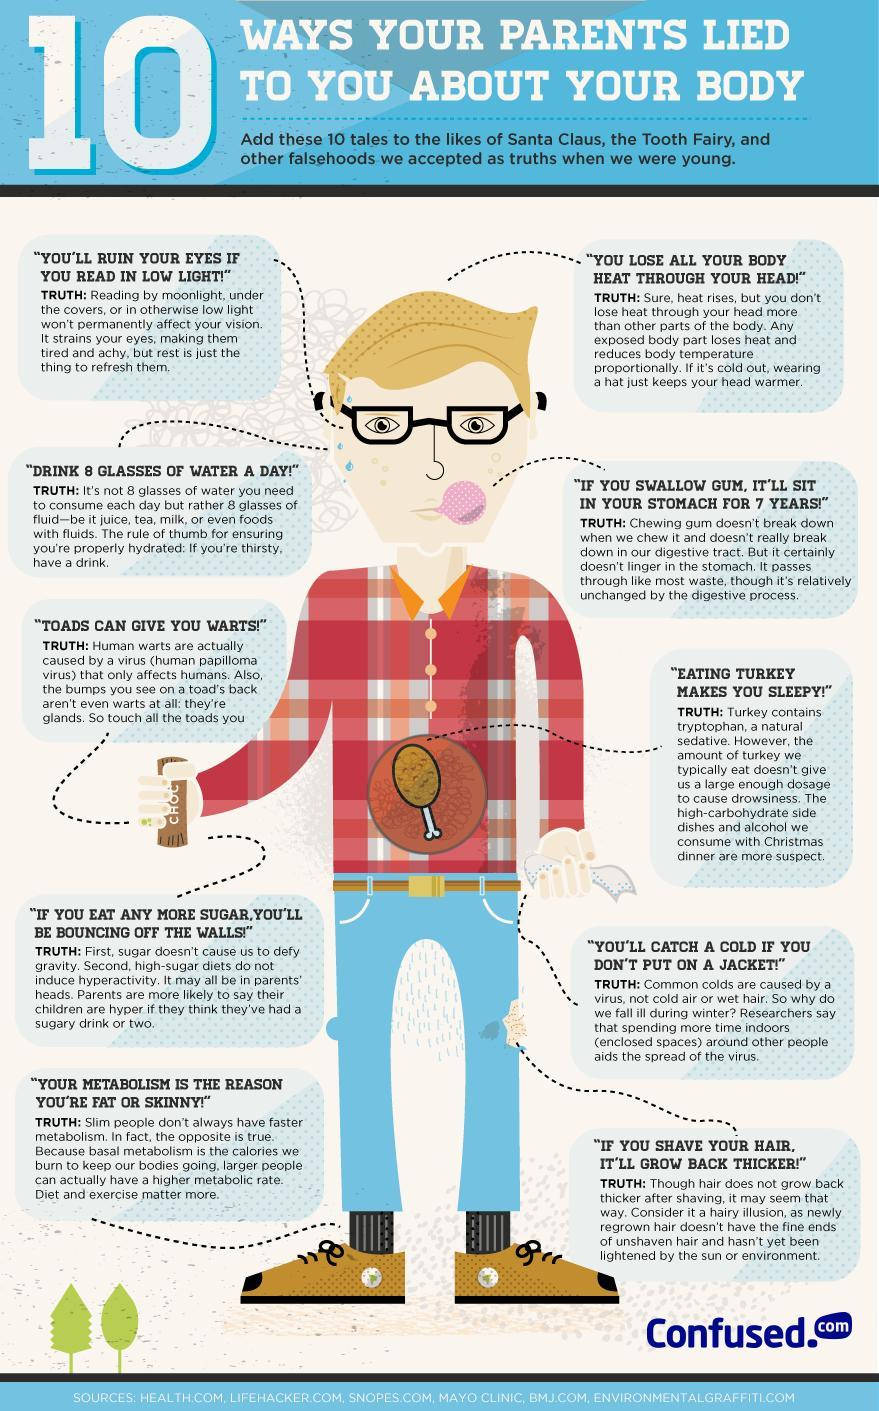What is the truth of reading under low light?
Answer the question with a short phrase. It strains your eyes, making them tired and achy How long a swallowed gum will stuck in your tummy? 7 Years 